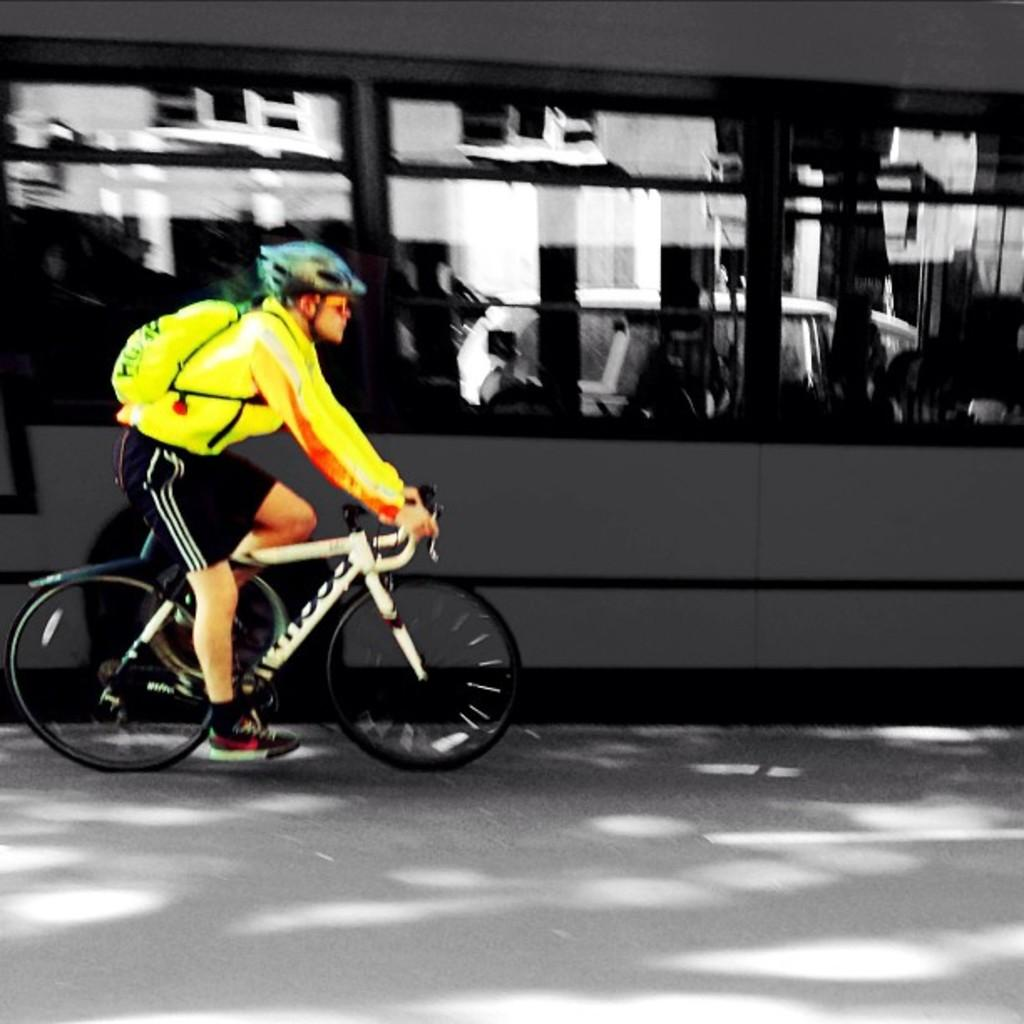What is the man in the image doing? The man is riding a bicycle in the image. What is the man wearing while riding the bicycle? The man is wearing a yellow shirt and black trousers. He is also wearing a bag and a helmet. What can be seen in the background of the image? There is a bus, a car, and a building in the background of the image. What is the man's location in the image? The man is on the road in the image. Can you see the man swimming in the ocean in the image? No, there is no ocean or swimming activity depicted in the image. The man is riding a bicycle on the road. 